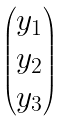Convert formula to latex. <formula><loc_0><loc_0><loc_500><loc_500>\begin{pmatrix} y _ { 1 } \\ y _ { 2 } \\ y _ { 3 } \\ \end{pmatrix}</formula> 